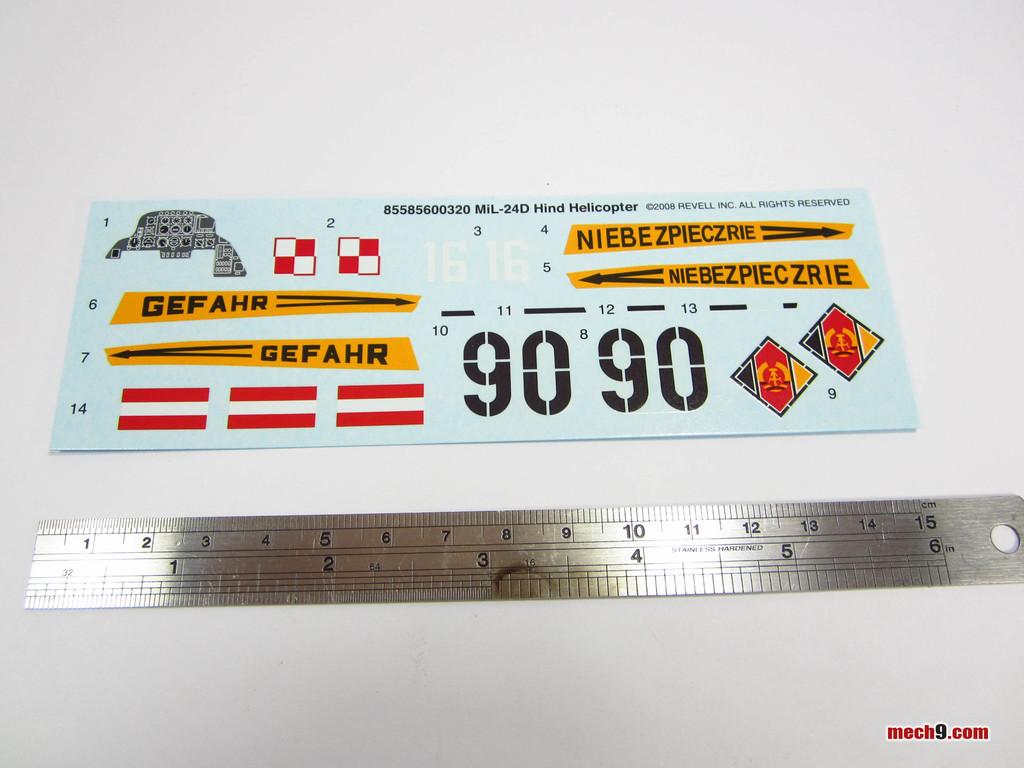What large numbers are on this sign?
Your answer should be very brief. 9090. 